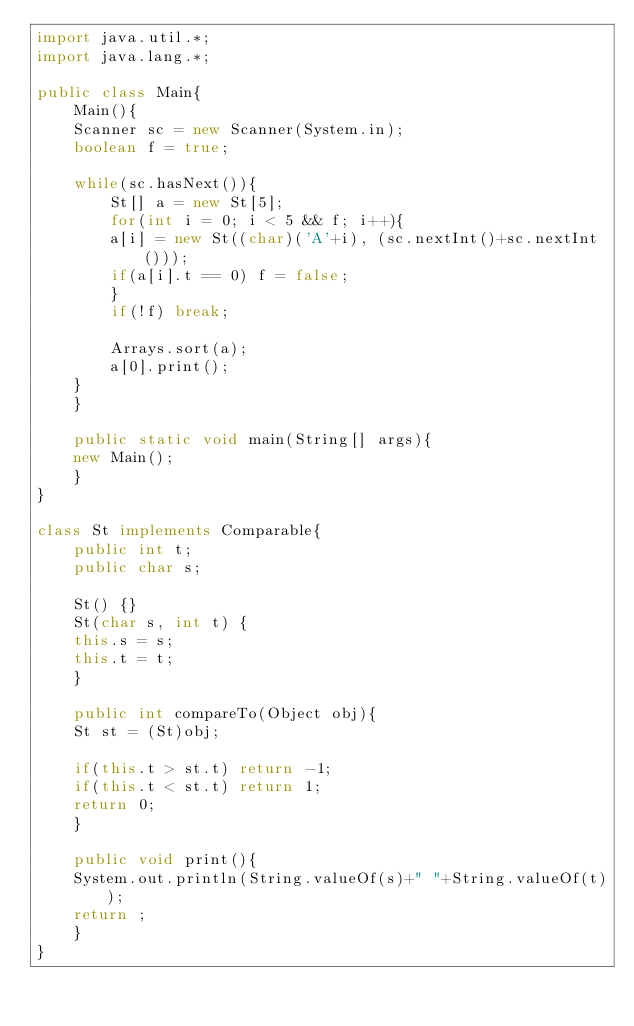<code> <loc_0><loc_0><loc_500><loc_500><_Java_>import java.util.*;
import java.lang.*;

public class Main{
    Main(){
	Scanner sc = new Scanner(System.in);
	boolean f = true;

	while(sc.hasNext()){
	    St[] a = new St[5];
	    for(int i = 0; i < 5 && f; i++){
		a[i] = new St((char)('A'+i), (sc.nextInt()+sc.nextInt()));
		if(a[i].t == 0) f = false;
	    }
	    if(!f) break;

	    Arrays.sort(a);
	    a[0].print();
	}
    }

    public static void main(String[] args){
	new Main();
    }
}

class St implements Comparable{
    public int t;
    public char s;

    St() {}
    St(char s, int t) {
	this.s = s;
	this.t = t;
    }

    public int compareTo(Object obj){
	St st = (St)obj;

	if(this.t > st.t) return -1;
	if(this.t < st.t) return 1;
	return 0;
    }

    public void print(){
	System.out.println(String.valueOf(s)+" "+String.valueOf(t));
	return ;
    }
}</code> 